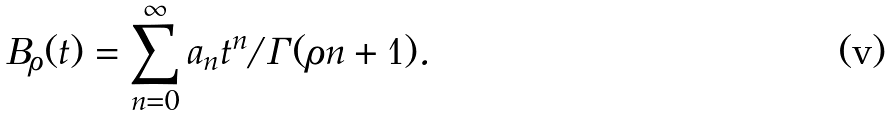Convert formula to latex. <formula><loc_0><loc_0><loc_500><loc_500>B _ { \rho } ( t ) = \sum _ { n = 0 } ^ { \infty } a _ { n } t ^ { n } / \Gamma ( \rho n + 1 ) .</formula> 